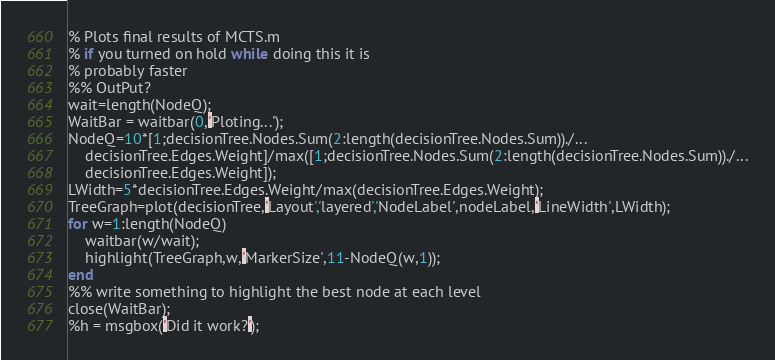Convert code to text. <code><loc_0><loc_0><loc_500><loc_500><_Julia_>% Plots final results of MCTS.m
% if you turned on hold while doing this it is
% probably faster
%% OutPut?
wait=length(NodeQ);
WaitBar = waitbar(0,'Ploting...');
NodeQ=10*[1;decisionTree.Nodes.Sum(2:length(decisionTree.Nodes.Sum))./...
    decisionTree.Edges.Weight]/max([1;decisionTree.Nodes.Sum(2:length(decisionTree.Nodes.Sum))./...
    decisionTree.Edges.Weight]);
LWidth=5*decisionTree.Edges.Weight/max(decisionTree.Edges.Weight);
TreeGraph=plot(decisionTree,'Layout','layered','NodeLabel',nodeLabel,'LineWidth',LWidth);
for w=1:length(NodeQ)
    waitbar(w/wait);
    highlight(TreeGraph,w,'MarkerSize',11-NodeQ(w,1));
end
%% write something to highlight the best node at each level
close(WaitBar);
%h = msgbox('Did it work?');</code> 